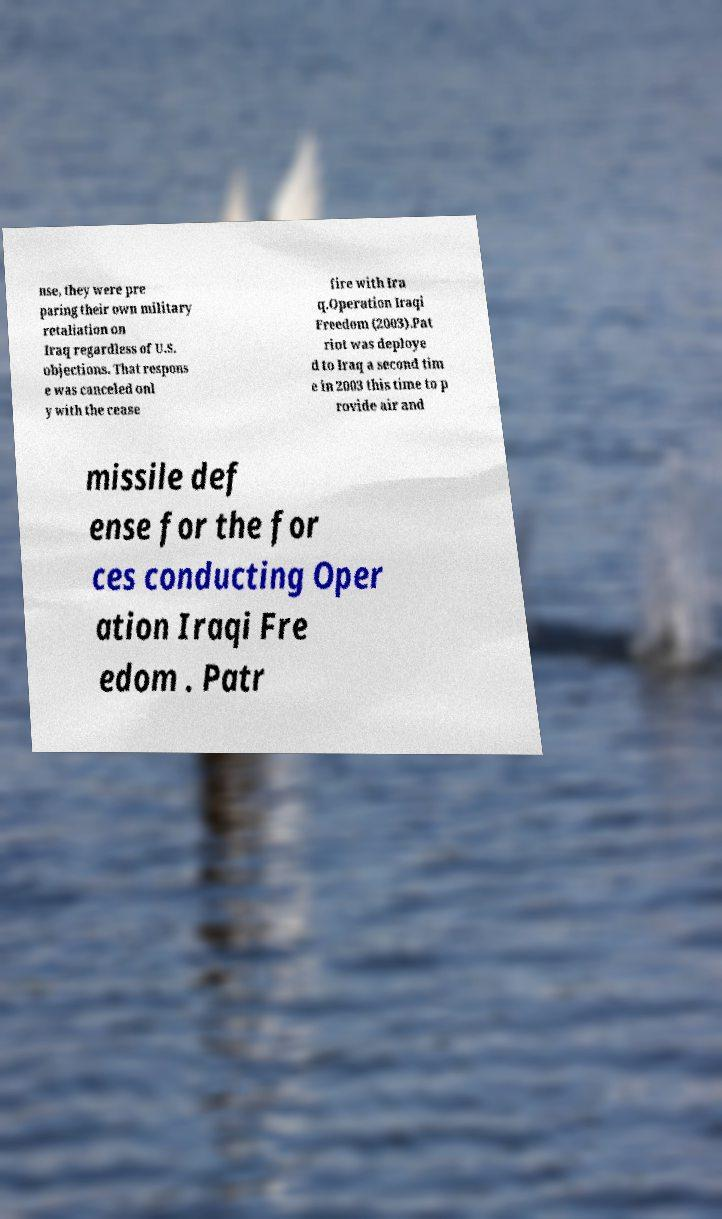Could you extract and type out the text from this image? nse, they were pre paring their own military retaliation on Iraq regardless of U.S. objections. That respons e was canceled onl y with the cease fire with Ira q.Operation Iraqi Freedom (2003).Pat riot was deploye d to Iraq a second tim e in 2003 this time to p rovide air and missile def ense for the for ces conducting Oper ation Iraqi Fre edom . Patr 